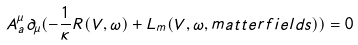Convert formula to latex. <formula><loc_0><loc_0><loc_500><loc_500>A _ { a } ^ { \mu } \partial _ { \mu } ( - \frac { 1 } { \kappa } R ( V , \omega ) + L _ { m } ( V , \omega , m a t t e r f i e l d s ) ) = 0</formula> 